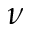<formula> <loc_0><loc_0><loc_500><loc_500>\nu</formula> 